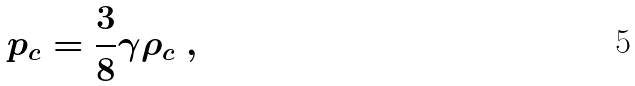Convert formula to latex. <formula><loc_0><loc_0><loc_500><loc_500>p _ { c } = \frac { 3 } { 8 } \gamma \rho _ { c } \ ,</formula> 